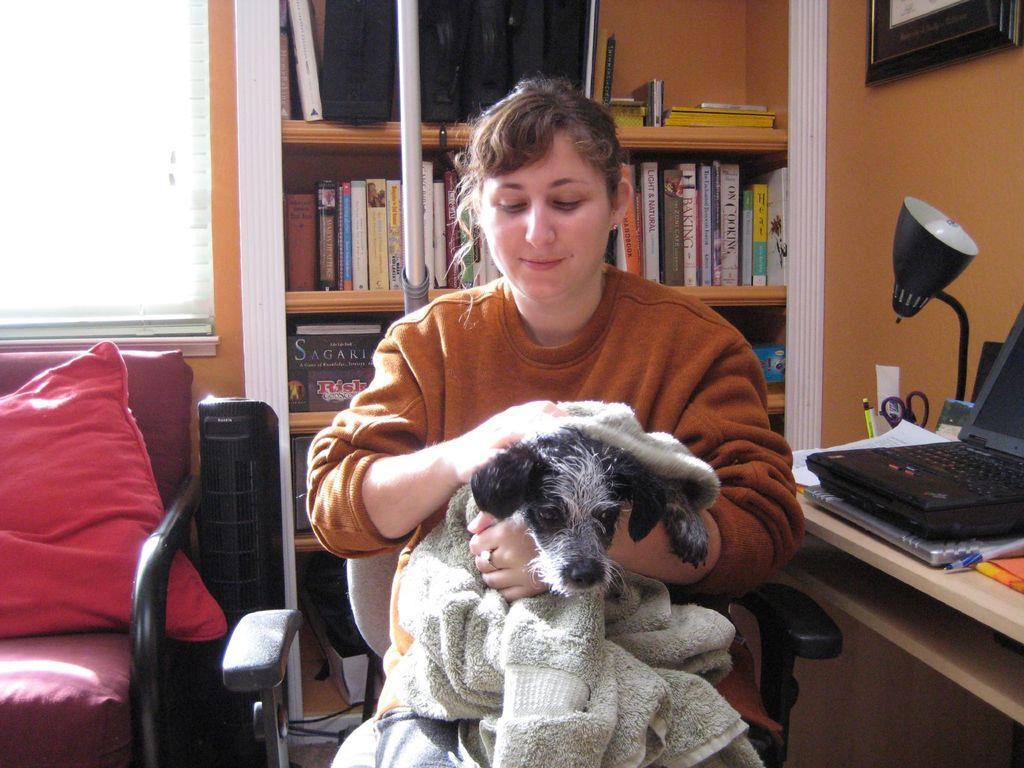Please provide a concise description of this image. In this picture we can see woman sitting on chair and wrapping towel to dog and smiling beside to her we can see laptop, lamp, scissor, papers on table and on other side pillows on chair and at back of her books in racks, pole, frame. 